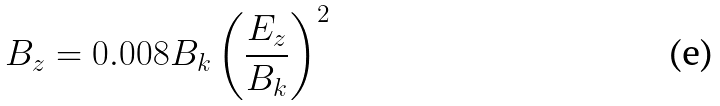<formula> <loc_0><loc_0><loc_500><loc_500>B _ { z } = 0 . 0 0 8 B _ { k } \left ( \frac { E _ { z } } { B _ { k } } \right ) ^ { 2 }</formula> 